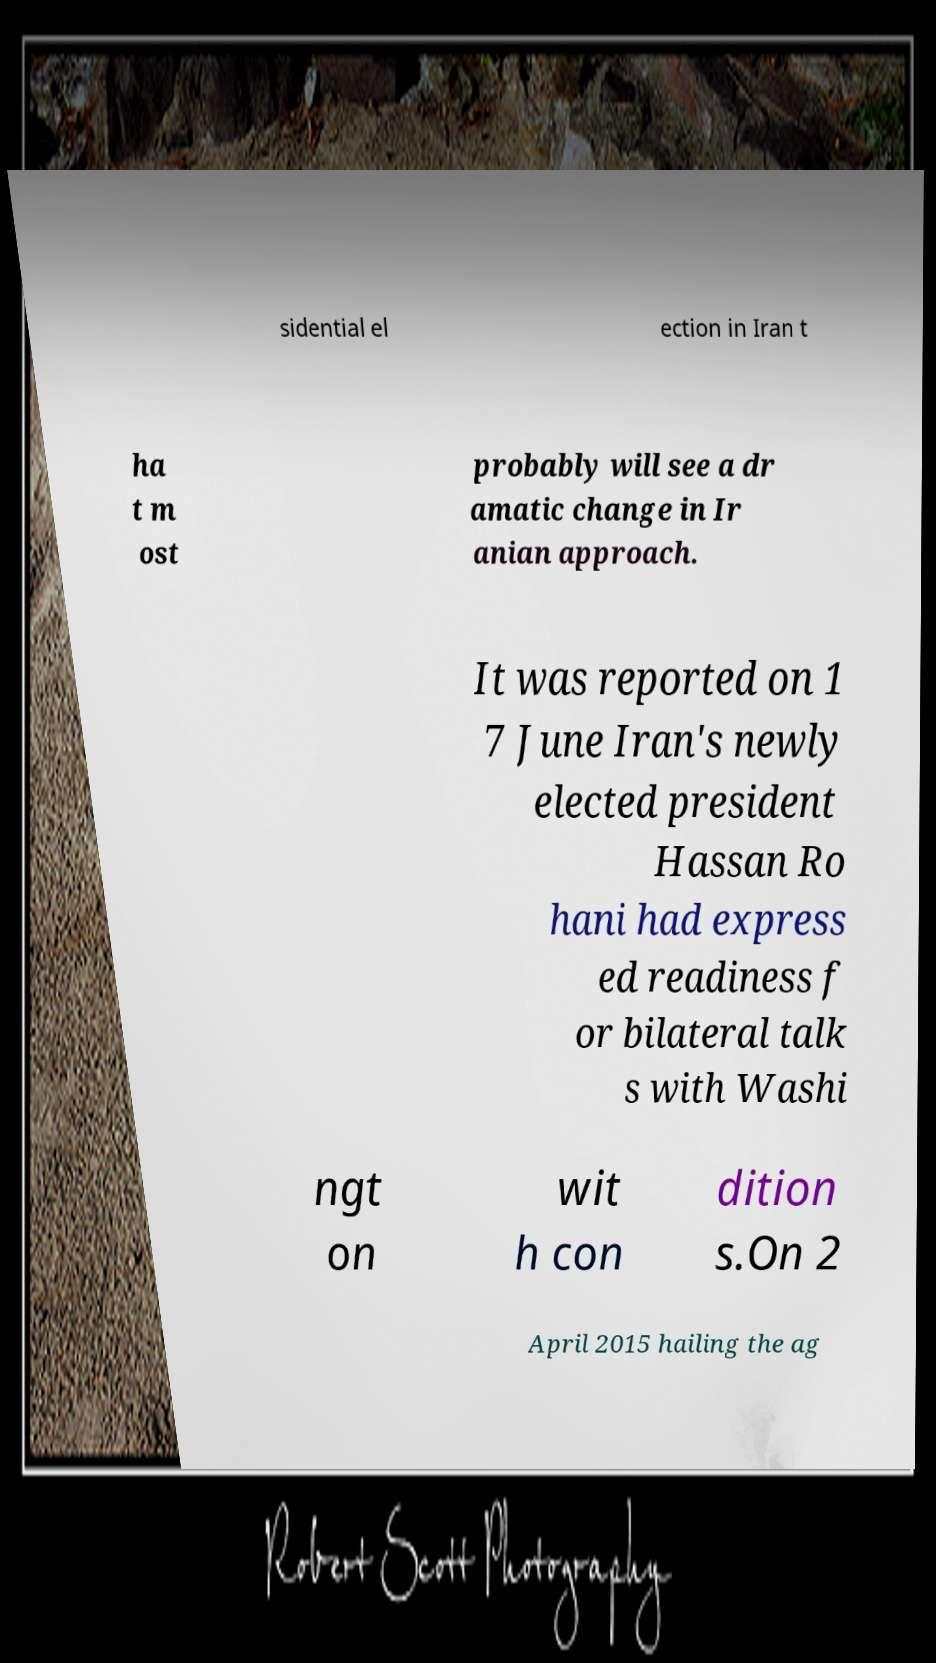Can you accurately transcribe the text from the provided image for me? sidential el ection in Iran t ha t m ost probably will see a dr amatic change in Ir anian approach. It was reported on 1 7 June Iran's newly elected president Hassan Ro hani had express ed readiness f or bilateral talk s with Washi ngt on wit h con dition s.On 2 April 2015 hailing the ag 